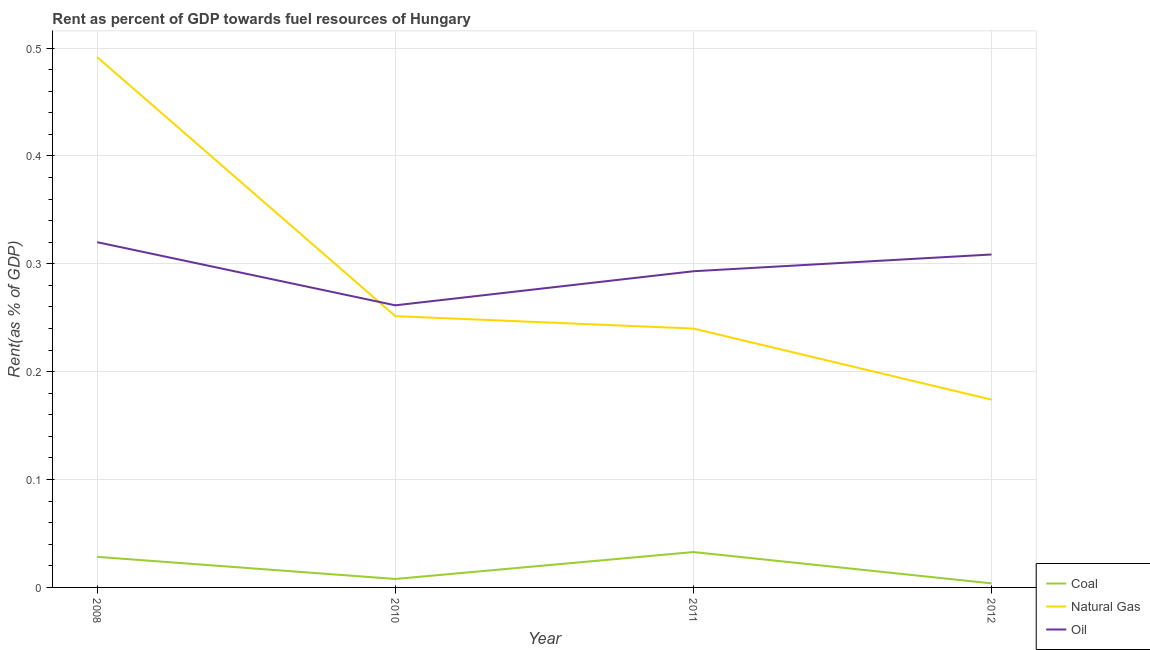What is the rent towards natural gas in 2008?
Make the answer very short. 0.49. Across all years, what is the maximum rent towards coal?
Keep it short and to the point. 0.03. Across all years, what is the minimum rent towards oil?
Offer a terse response. 0.26. In which year was the rent towards coal maximum?
Offer a terse response. 2011. In which year was the rent towards coal minimum?
Offer a terse response. 2012. What is the total rent towards coal in the graph?
Offer a terse response. 0.07. What is the difference between the rent towards oil in 2011 and that in 2012?
Give a very brief answer. -0.02. What is the difference between the rent towards oil in 2010 and the rent towards natural gas in 2008?
Provide a short and direct response. -0.23. What is the average rent towards coal per year?
Give a very brief answer. 0.02. In the year 2011, what is the difference between the rent towards natural gas and rent towards coal?
Make the answer very short. 0.21. In how many years, is the rent towards natural gas greater than 0.22 %?
Make the answer very short. 3. What is the ratio of the rent towards natural gas in 2010 to that in 2012?
Offer a very short reply. 1.44. Is the rent towards oil in 2008 less than that in 2012?
Ensure brevity in your answer.  No. What is the difference between the highest and the second highest rent towards coal?
Keep it short and to the point. 0. What is the difference between the highest and the lowest rent towards coal?
Provide a succinct answer. 0.03. In how many years, is the rent towards coal greater than the average rent towards coal taken over all years?
Offer a very short reply. 2. Is it the case that in every year, the sum of the rent towards coal and rent towards natural gas is greater than the rent towards oil?
Offer a very short reply. No. Is the rent towards coal strictly greater than the rent towards natural gas over the years?
Make the answer very short. No. How many lines are there?
Give a very brief answer. 3. What is the difference between two consecutive major ticks on the Y-axis?
Offer a terse response. 0.1. Are the values on the major ticks of Y-axis written in scientific E-notation?
Your answer should be compact. No. Does the graph contain any zero values?
Provide a short and direct response. No. Where does the legend appear in the graph?
Offer a terse response. Bottom right. How many legend labels are there?
Keep it short and to the point. 3. How are the legend labels stacked?
Make the answer very short. Vertical. What is the title of the graph?
Make the answer very short. Rent as percent of GDP towards fuel resources of Hungary. What is the label or title of the X-axis?
Keep it short and to the point. Year. What is the label or title of the Y-axis?
Ensure brevity in your answer.  Rent(as % of GDP). What is the Rent(as % of GDP) of Coal in 2008?
Offer a terse response. 0.03. What is the Rent(as % of GDP) of Natural Gas in 2008?
Provide a short and direct response. 0.49. What is the Rent(as % of GDP) in Oil in 2008?
Provide a short and direct response. 0.32. What is the Rent(as % of GDP) in Coal in 2010?
Ensure brevity in your answer.  0.01. What is the Rent(as % of GDP) in Natural Gas in 2010?
Ensure brevity in your answer.  0.25. What is the Rent(as % of GDP) of Oil in 2010?
Provide a short and direct response. 0.26. What is the Rent(as % of GDP) in Coal in 2011?
Provide a short and direct response. 0.03. What is the Rent(as % of GDP) in Natural Gas in 2011?
Give a very brief answer. 0.24. What is the Rent(as % of GDP) in Oil in 2011?
Keep it short and to the point. 0.29. What is the Rent(as % of GDP) in Coal in 2012?
Give a very brief answer. 0. What is the Rent(as % of GDP) in Natural Gas in 2012?
Your answer should be compact. 0.17. What is the Rent(as % of GDP) in Oil in 2012?
Offer a very short reply. 0.31. Across all years, what is the maximum Rent(as % of GDP) in Coal?
Offer a terse response. 0.03. Across all years, what is the maximum Rent(as % of GDP) in Natural Gas?
Make the answer very short. 0.49. Across all years, what is the maximum Rent(as % of GDP) of Oil?
Offer a very short reply. 0.32. Across all years, what is the minimum Rent(as % of GDP) of Coal?
Provide a short and direct response. 0. Across all years, what is the minimum Rent(as % of GDP) of Natural Gas?
Make the answer very short. 0.17. Across all years, what is the minimum Rent(as % of GDP) in Oil?
Make the answer very short. 0.26. What is the total Rent(as % of GDP) in Coal in the graph?
Keep it short and to the point. 0.07. What is the total Rent(as % of GDP) in Natural Gas in the graph?
Offer a terse response. 1.16. What is the total Rent(as % of GDP) of Oil in the graph?
Your response must be concise. 1.18. What is the difference between the Rent(as % of GDP) in Coal in 2008 and that in 2010?
Provide a succinct answer. 0.02. What is the difference between the Rent(as % of GDP) of Natural Gas in 2008 and that in 2010?
Give a very brief answer. 0.24. What is the difference between the Rent(as % of GDP) in Oil in 2008 and that in 2010?
Make the answer very short. 0.06. What is the difference between the Rent(as % of GDP) of Coal in 2008 and that in 2011?
Provide a succinct answer. -0. What is the difference between the Rent(as % of GDP) in Natural Gas in 2008 and that in 2011?
Make the answer very short. 0.25. What is the difference between the Rent(as % of GDP) of Oil in 2008 and that in 2011?
Ensure brevity in your answer.  0.03. What is the difference between the Rent(as % of GDP) in Coal in 2008 and that in 2012?
Give a very brief answer. 0.02. What is the difference between the Rent(as % of GDP) of Natural Gas in 2008 and that in 2012?
Your answer should be compact. 0.32. What is the difference between the Rent(as % of GDP) of Oil in 2008 and that in 2012?
Give a very brief answer. 0.01. What is the difference between the Rent(as % of GDP) of Coal in 2010 and that in 2011?
Keep it short and to the point. -0.03. What is the difference between the Rent(as % of GDP) in Natural Gas in 2010 and that in 2011?
Make the answer very short. 0.01. What is the difference between the Rent(as % of GDP) in Oil in 2010 and that in 2011?
Offer a very short reply. -0.03. What is the difference between the Rent(as % of GDP) of Coal in 2010 and that in 2012?
Offer a very short reply. 0. What is the difference between the Rent(as % of GDP) in Natural Gas in 2010 and that in 2012?
Give a very brief answer. 0.08. What is the difference between the Rent(as % of GDP) in Oil in 2010 and that in 2012?
Your response must be concise. -0.05. What is the difference between the Rent(as % of GDP) of Coal in 2011 and that in 2012?
Offer a very short reply. 0.03. What is the difference between the Rent(as % of GDP) of Natural Gas in 2011 and that in 2012?
Keep it short and to the point. 0.07. What is the difference between the Rent(as % of GDP) in Oil in 2011 and that in 2012?
Make the answer very short. -0.02. What is the difference between the Rent(as % of GDP) of Coal in 2008 and the Rent(as % of GDP) of Natural Gas in 2010?
Offer a very short reply. -0.22. What is the difference between the Rent(as % of GDP) in Coal in 2008 and the Rent(as % of GDP) in Oil in 2010?
Your answer should be compact. -0.23. What is the difference between the Rent(as % of GDP) of Natural Gas in 2008 and the Rent(as % of GDP) of Oil in 2010?
Offer a terse response. 0.23. What is the difference between the Rent(as % of GDP) of Coal in 2008 and the Rent(as % of GDP) of Natural Gas in 2011?
Your answer should be compact. -0.21. What is the difference between the Rent(as % of GDP) in Coal in 2008 and the Rent(as % of GDP) in Oil in 2011?
Provide a short and direct response. -0.26. What is the difference between the Rent(as % of GDP) of Natural Gas in 2008 and the Rent(as % of GDP) of Oil in 2011?
Offer a terse response. 0.2. What is the difference between the Rent(as % of GDP) of Coal in 2008 and the Rent(as % of GDP) of Natural Gas in 2012?
Offer a very short reply. -0.15. What is the difference between the Rent(as % of GDP) of Coal in 2008 and the Rent(as % of GDP) of Oil in 2012?
Your answer should be compact. -0.28. What is the difference between the Rent(as % of GDP) in Natural Gas in 2008 and the Rent(as % of GDP) in Oil in 2012?
Make the answer very short. 0.18. What is the difference between the Rent(as % of GDP) in Coal in 2010 and the Rent(as % of GDP) in Natural Gas in 2011?
Make the answer very short. -0.23. What is the difference between the Rent(as % of GDP) of Coal in 2010 and the Rent(as % of GDP) of Oil in 2011?
Provide a succinct answer. -0.29. What is the difference between the Rent(as % of GDP) in Natural Gas in 2010 and the Rent(as % of GDP) in Oil in 2011?
Ensure brevity in your answer.  -0.04. What is the difference between the Rent(as % of GDP) of Coal in 2010 and the Rent(as % of GDP) of Natural Gas in 2012?
Offer a very short reply. -0.17. What is the difference between the Rent(as % of GDP) in Coal in 2010 and the Rent(as % of GDP) in Oil in 2012?
Make the answer very short. -0.3. What is the difference between the Rent(as % of GDP) in Natural Gas in 2010 and the Rent(as % of GDP) in Oil in 2012?
Offer a terse response. -0.06. What is the difference between the Rent(as % of GDP) of Coal in 2011 and the Rent(as % of GDP) of Natural Gas in 2012?
Your answer should be very brief. -0.14. What is the difference between the Rent(as % of GDP) in Coal in 2011 and the Rent(as % of GDP) in Oil in 2012?
Keep it short and to the point. -0.28. What is the difference between the Rent(as % of GDP) in Natural Gas in 2011 and the Rent(as % of GDP) in Oil in 2012?
Offer a terse response. -0.07. What is the average Rent(as % of GDP) in Coal per year?
Your answer should be compact. 0.02. What is the average Rent(as % of GDP) in Natural Gas per year?
Your answer should be very brief. 0.29. What is the average Rent(as % of GDP) in Oil per year?
Your answer should be compact. 0.3. In the year 2008, what is the difference between the Rent(as % of GDP) in Coal and Rent(as % of GDP) in Natural Gas?
Provide a succinct answer. -0.46. In the year 2008, what is the difference between the Rent(as % of GDP) of Coal and Rent(as % of GDP) of Oil?
Your answer should be very brief. -0.29. In the year 2008, what is the difference between the Rent(as % of GDP) of Natural Gas and Rent(as % of GDP) of Oil?
Provide a succinct answer. 0.17. In the year 2010, what is the difference between the Rent(as % of GDP) in Coal and Rent(as % of GDP) in Natural Gas?
Ensure brevity in your answer.  -0.24. In the year 2010, what is the difference between the Rent(as % of GDP) in Coal and Rent(as % of GDP) in Oil?
Make the answer very short. -0.25. In the year 2010, what is the difference between the Rent(as % of GDP) of Natural Gas and Rent(as % of GDP) of Oil?
Offer a terse response. -0.01. In the year 2011, what is the difference between the Rent(as % of GDP) of Coal and Rent(as % of GDP) of Natural Gas?
Keep it short and to the point. -0.21. In the year 2011, what is the difference between the Rent(as % of GDP) of Coal and Rent(as % of GDP) of Oil?
Provide a short and direct response. -0.26. In the year 2011, what is the difference between the Rent(as % of GDP) of Natural Gas and Rent(as % of GDP) of Oil?
Ensure brevity in your answer.  -0.05. In the year 2012, what is the difference between the Rent(as % of GDP) in Coal and Rent(as % of GDP) in Natural Gas?
Give a very brief answer. -0.17. In the year 2012, what is the difference between the Rent(as % of GDP) in Coal and Rent(as % of GDP) in Oil?
Provide a short and direct response. -0.3. In the year 2012, what is the difference between the Rent(as % of GDP) of Natural Gas and Rent(as % of GDP) of Oil?
Your answer should be very brief. -0.13. What is the ratio of the Rent(as % of GDP) of Coal in 2008 to that in 2010?
Keep it short and to the point. 3.61. What is the ratio of the Rent(as % of GDP) of Natural Gas in 2008 to that in 2010?
Ensure brevity in your answer.  1.95. What is the ratio of the Rent(as % of GDP) in Oil in 2008 to that in 2010?
Your answer should be compact. 1.22. What is the ratio of the Rent(as % of GDP) of Coal in 2008 to that in 2011?
Offer a terse response. 0.86. What is the ratio of the Rent(as % of GDP) of Natural Gas in 2008 to that in 2011?
Your response must be concise. 2.05. What is the ratio of the Rent(as % of GDP) in Oil in 2008 to that in 2011?
Your response must be concise. 1.09. What is the ratio of the Rent(as % of GDP) in Coal in 2008 to that in 2012?
Your response must be concise. 7.53. What is the ratio of the Rent(as % of GDP) of Natural Gas in 2008 to that in 2012?
Your response must be concise. 2.82. What is the ratio of the Rent(as % of GDP) of Coal in 2010 to that in 2011?
Keep it short and to the point. 0.24. What is the ratio of the Rent(as % of GDP) in Natural Gas in 2010 to that in 2011?
Provide a short and direct response. 1.05. What is the ratio of the Rent(as % of GDP) in Oil in 2010 to that in 2011?
Keep it short and to the point. 0.89. What is the ratio of the Rent(as % of GDP) of Coal in 2010 to that in 2012?
Offer a very short reply. 2.08. What is the ratio of the Rent(as % of GDP) of Natural Gas in 2010 to that in 2012?
Provide a succinct answer. 1.44. What is the ratio of the Rent(as % of GDP) in Oil in 2010 to that in 2012?
Ensure brevity in your answer.  0.85. What is the ratio of the Rent(as % of GDP) of Coal in 2011 to that in 2012?
Your response must be concise. 8.72. What is the ratio of the Rent(as % of GDP) of Natural Gas in 2011 to that in 2012?
Make the answer very short. 1.38. What is the ratio of the Rent(as % of GDP) of Oil in 2011 to that in 2012?
Your answer should be very brief. 0.95. What is the difference between the highest and the second highest Rent(as % of GDP) of Coal?
Give a very brief answer. 0. What is the difference between the highest and the second highest Rent(as % of GDP) in Natural Gas?
Provide a short and direct response. 0.24. What is the difference between the highest and the second highest Rent(as % of GDP) of Oil?
Your answer should be compact. 0.01. What is the difference between the highest and the lowest Rent(as % of GDP) in Coal?
Ensure brevity in your answer.  0.03. What is the difference between the highest and the lowest Rent(as % of GDP) of Natural Gas?
Your answer should be compact. 0.32. What is the difference between the highest and the lowest Rent(as % of GDP) in Oil?
Ensure brevity in your answer.  0.06. 